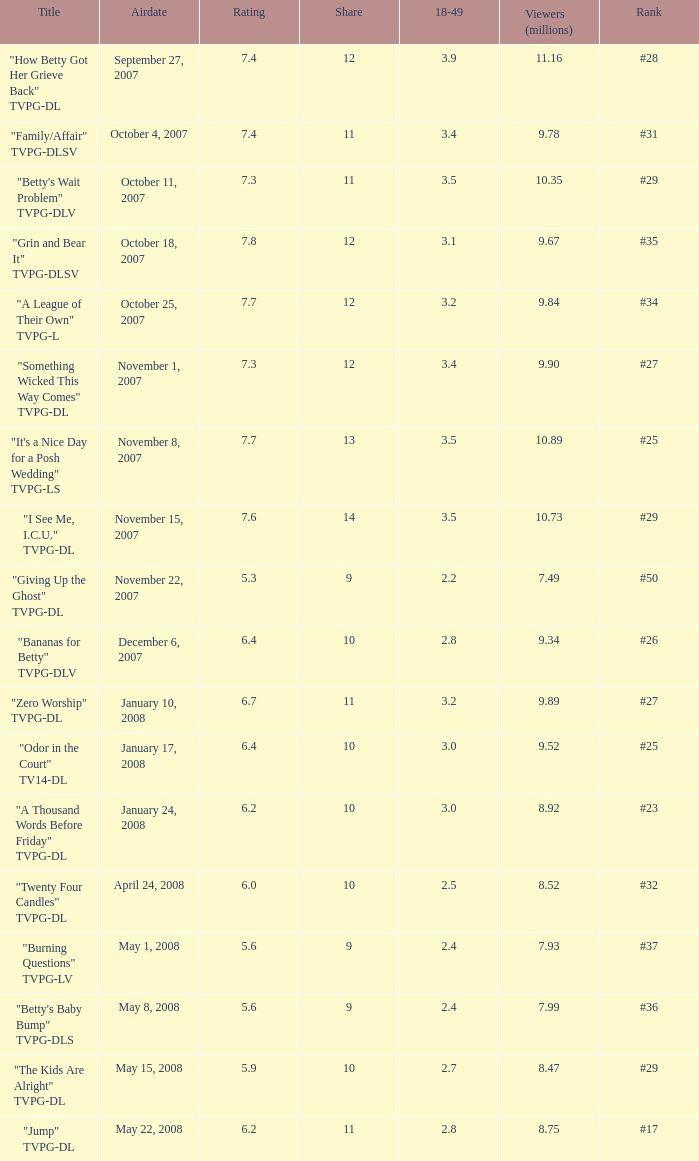What is the release date of the episode that ranked #29 and had a share greater than 10? May 15, 2008. 